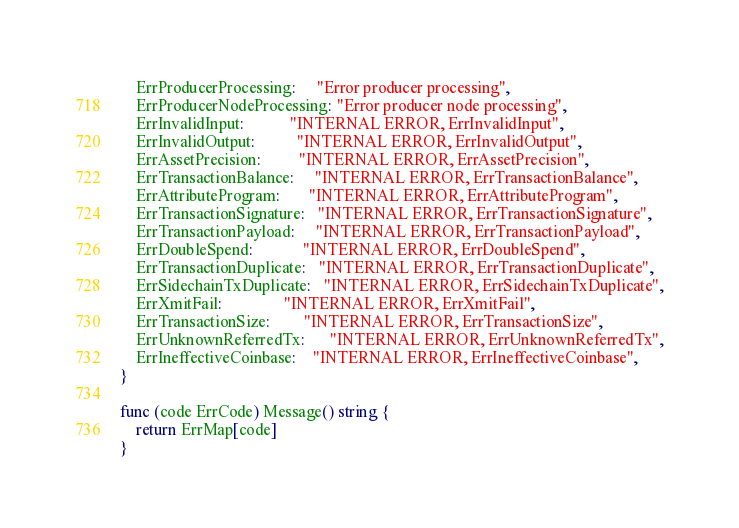Convert code to text. <code><loc_0><loc_0><loc_500><loc_500><_Go_>	ErrProducerProcessing:     "Error producer processing",
	ErrProducerNodeProcessing: "Error producer node processing",
	ErrInvalidInput:           "INTERNAL ERROR, ErrInvalidInput",
	ErrInvalidOutput:          "INTERNAL ERROR, ErrInvalidOutput",
	ErrAssetPrecision:         "INTERNAL ERROR, ErrAssetPrecision",
	ErrTransactionBalance:     "INTERNAL ERROR, ErrTransactionBalance",
	ErrAttributeProgram:       "INTERNAL ERROR, ErrAttributeProgram",
	ErrTransactionSignature:   "INTERNAL ERROR, ErrTransactionSignature",
	ErrTransactionPayload:     "INTERNAL ERROR, ErrTransactionPayload",
	ErrDoubleSpend:            "INTERNAL ERROR, ErrDoubleSpend",
	ErrTransactionDuplicate:   "INTERNAL ERROR, ErrTransactionDuplicate",
	ErrSidechainTxDuplicate:   "INTERNAL ERROR, ErrSidechainTxDuplicate",
	ErrXmitFail:               "INTERNAL ERROR, ErrXmitFail",
	ErrTransactionSize:        "INTERNAL ERROR, ErrTransactionSize",
	ErrUnknownReferredTx:      "INTERNAL ERROR, ErrUnknownReferredTx",
	ErrIneffectiveCoinbase:    "INTERNAL ERROR, ErrIneffectiveCoinbase",
}

func (code ErrCode) Message() string {
	return ErrMap[code]
}
</code> 